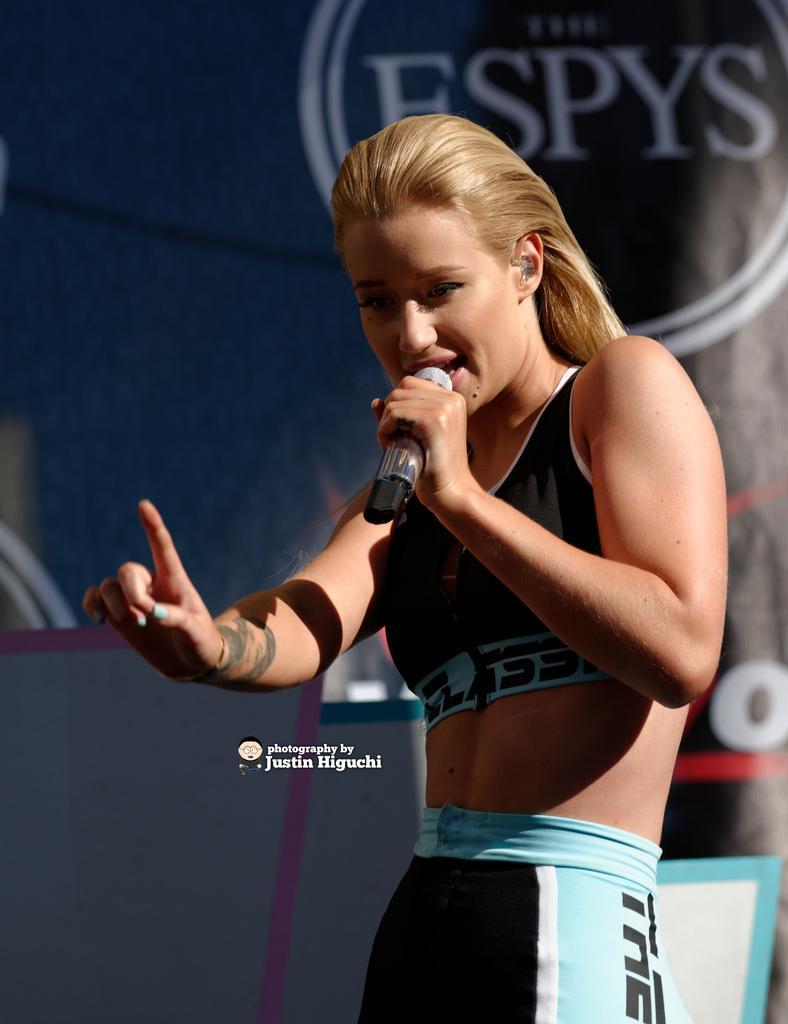In one or two sentences, can you explain what this image depicts? In the center of the image we can see a lady is standing and holding a mic and talking. In the background of the image we can see the boards. In the middle of the image we can see the text. 